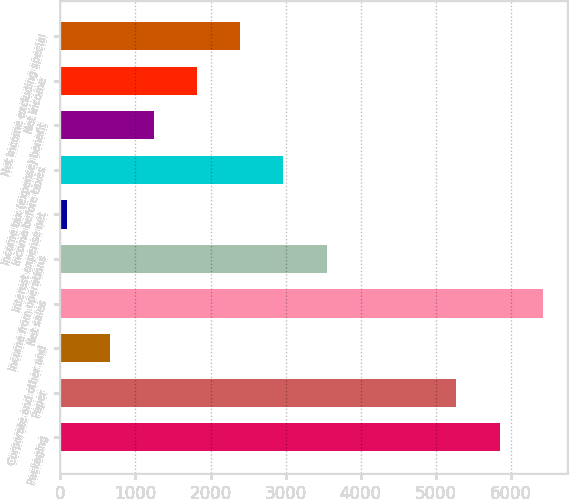Convert chart to OTSL. <chart><loc_0><loc_0><loc_500><loc_500><bar_chart><fcel>Packaging<fcel>Paper<fcel>Corporate and other and<fcel>Net sales<fcel>Income from operations<fcel>Interest expense net<fcel>Income before taxes<fcel>Income tax (expense) benefit<fcel>Net income<fcel>Net income excluding special<nl><fcel>5852.6<fcel>5276.18<fcel>664.82<fcel>6429.02<fcel>3546.92<fcel>88.4<fcel>2970.5<fcel>1241.24<fcel>1817.66<fcel>2394.08<nl></chart> 